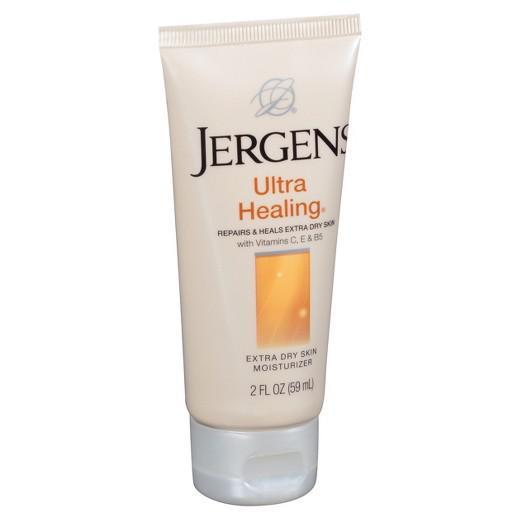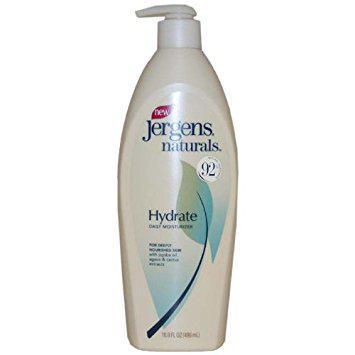The first image is the image on the left, the second image is the image on the right. For the images displayed, is the sentence "The bottle in the image on the right is turned at a slight angle." factually correct? Answer yes or no. No. The first image is the image on the left, the second image is the image on the right. Evaluate the accuracy of this statement regarding the images: "There are two bottles, and only one of them has a pump.". Is it true? Answer yes or no. Yes. 